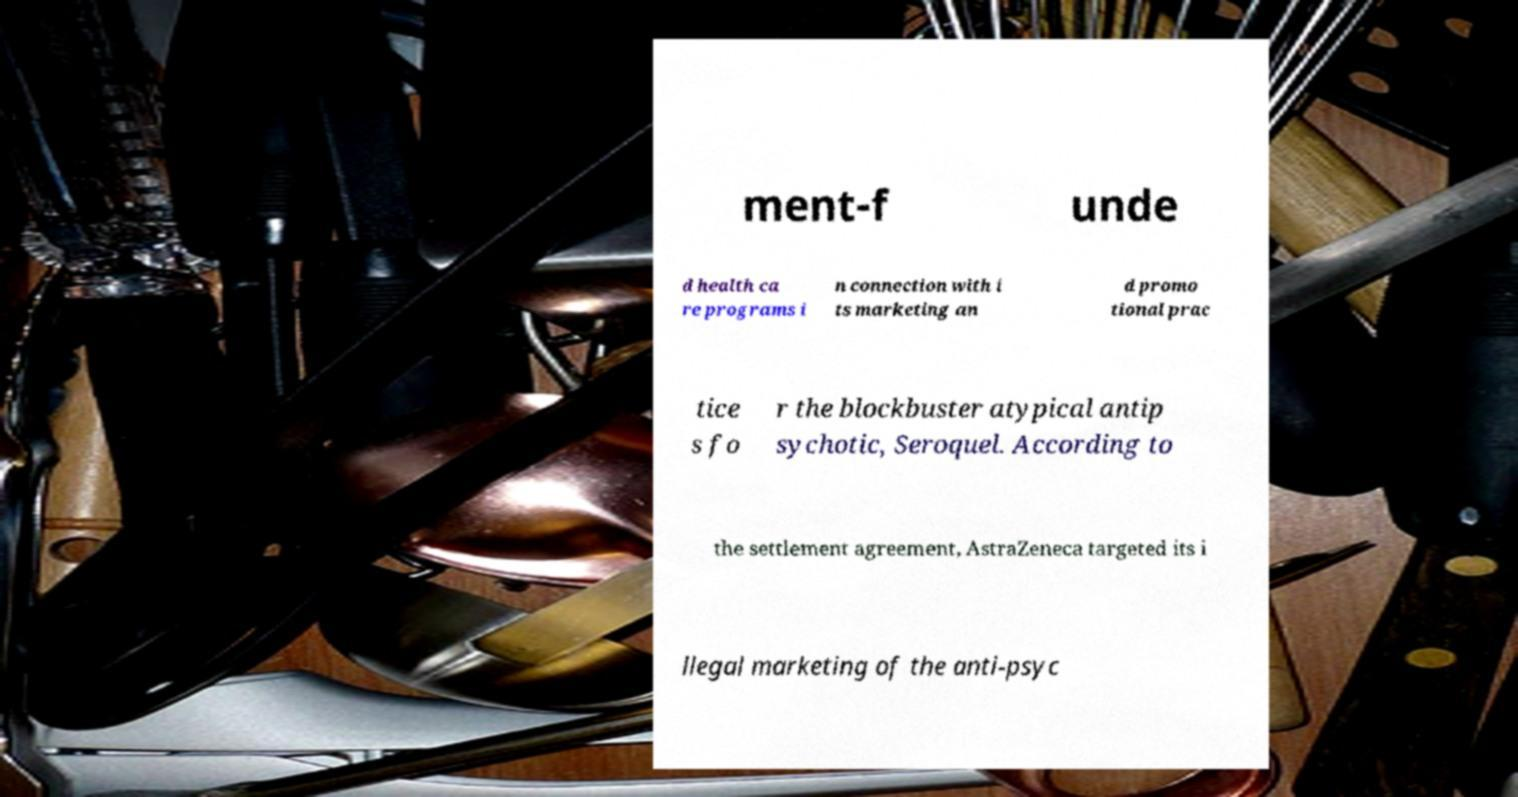Could you assist in decoding the text presented in this image and type it out clearly? ment-f unde d health ca re programs i n connection with i ts marketing an d promo tional prac tice s fo r the blockbuster atypical antip sychotic, Seroquel. According to the settlement agreement, AstraZeneca targeted its i llegal marketing of the anti-psyc 